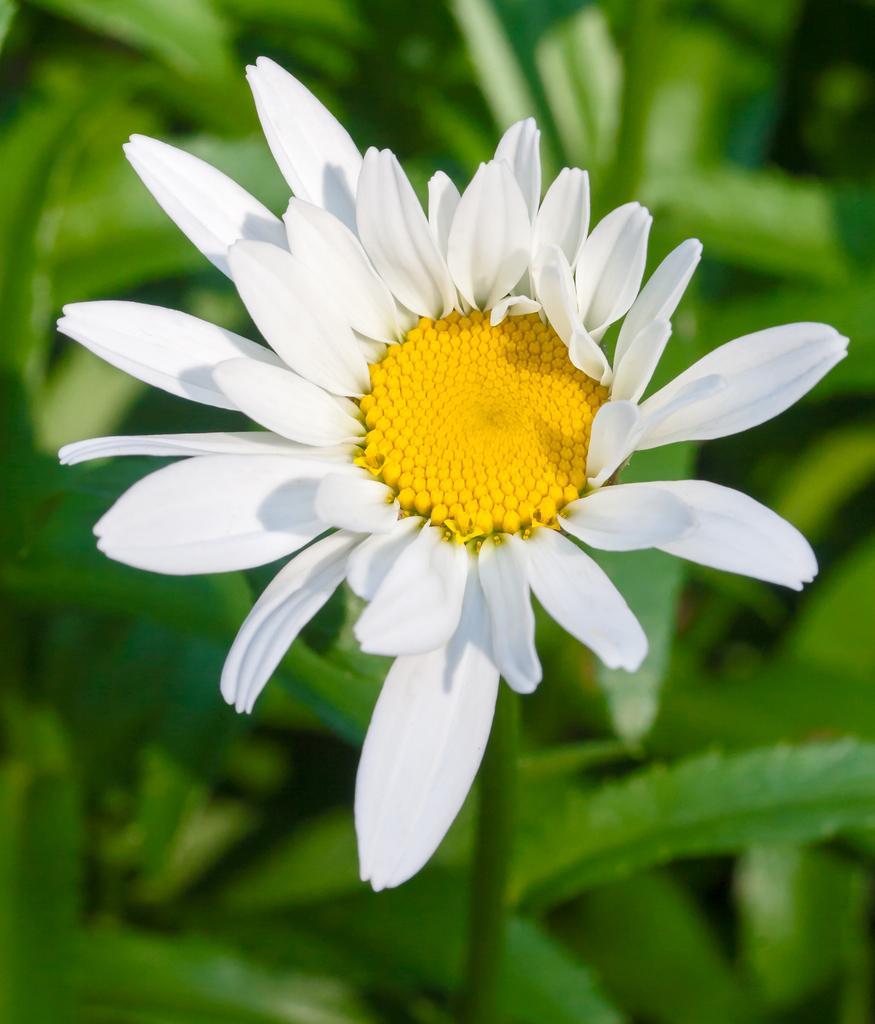Can you describe this image briefly? In this picture there is a flower on the plant. At the bottom I can see many leaves. 